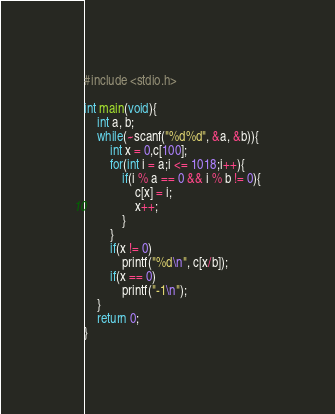<code> <loc_0><loc_0><loc_500><loc_500><_C_>#include <stdio.h>

int main(void){
    int a, b;
    while(~scanf("%d%d", &a, &b)){
        int x = 0,c[100];
        for(int i = a;i <= 1018;i++){
            if(i % a == 0 && i % b != 0){
                c[x] = i;
                x++;
            }
        }
        if(x != 0)
            printf("%d\n", c[x/b]);
        if(x == 0)
            printf("-1\n");
    }
    return 0;
}
</code> 